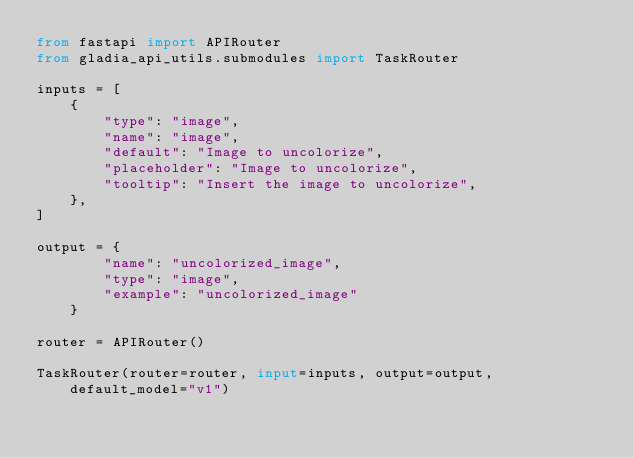<code> <loc_0><loc_0><loc_500><loc_500><_Python_>from fastapi import APIRouter
from gladia_api_utils.submodules import TaskRouter

inputs = [
    {
        "type": "image",
        "name": "image",
        "default": "Image to uncolorize",
        "placeholder": "Image to uncolorize",
        "tooltip": "Insert the image to uncolorize",
    },
]

output = {
        "name": "uncolorized_image",
        "type": "image",
        "example": "uncolorized_image"
    }

router = APIRouter()

TaskRouter(router=router, input=inputs, output=output, default_model="v1")
</code> 